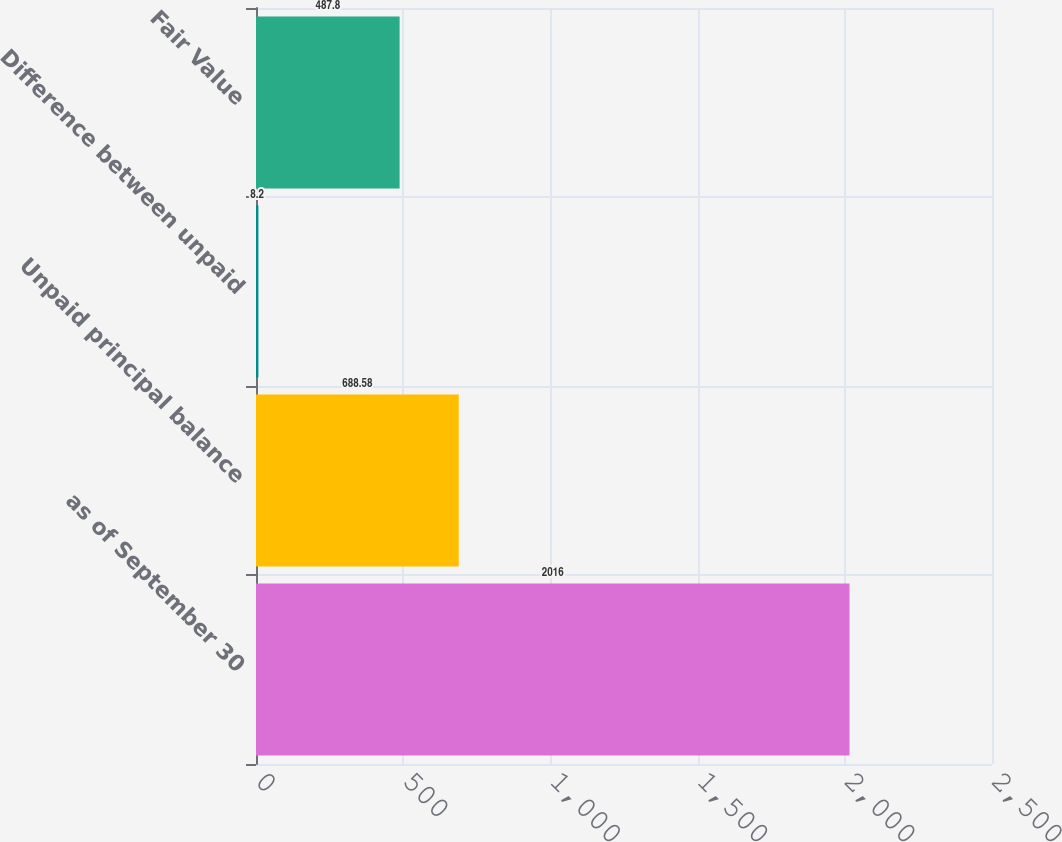Convert chart to OTSL. <chart><loc_0><loc_0><loc_500><loc_500><bar_chart><fcel>as of September 30<fcel>Unpaid principal balance<fcel>Difference between unpaid<fcel>Fair Value<nl><fcel>2016<fcel>688.58<fcel>8.2<fcel>487.8<nl></chart> 